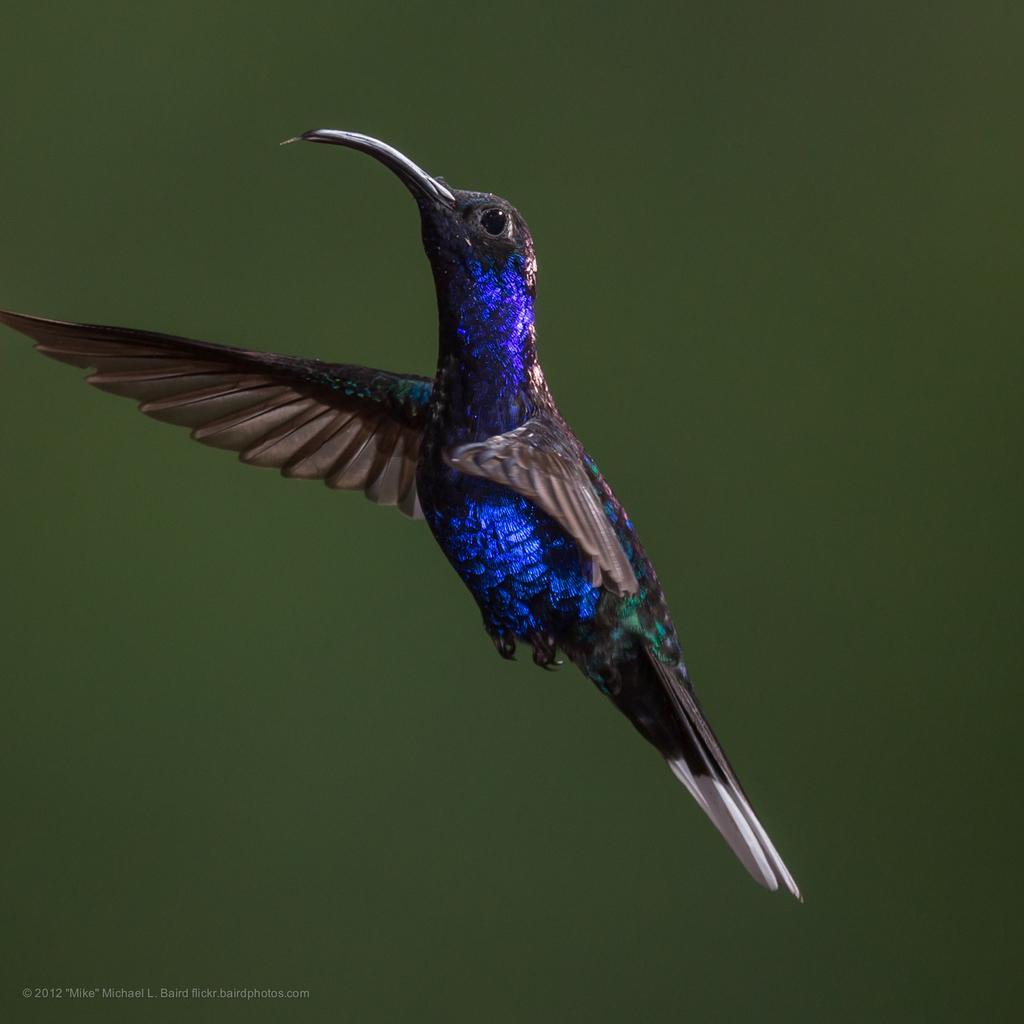Describe this image in one or two sentences. In this image we can see a bird. The background of the image is blurred. 